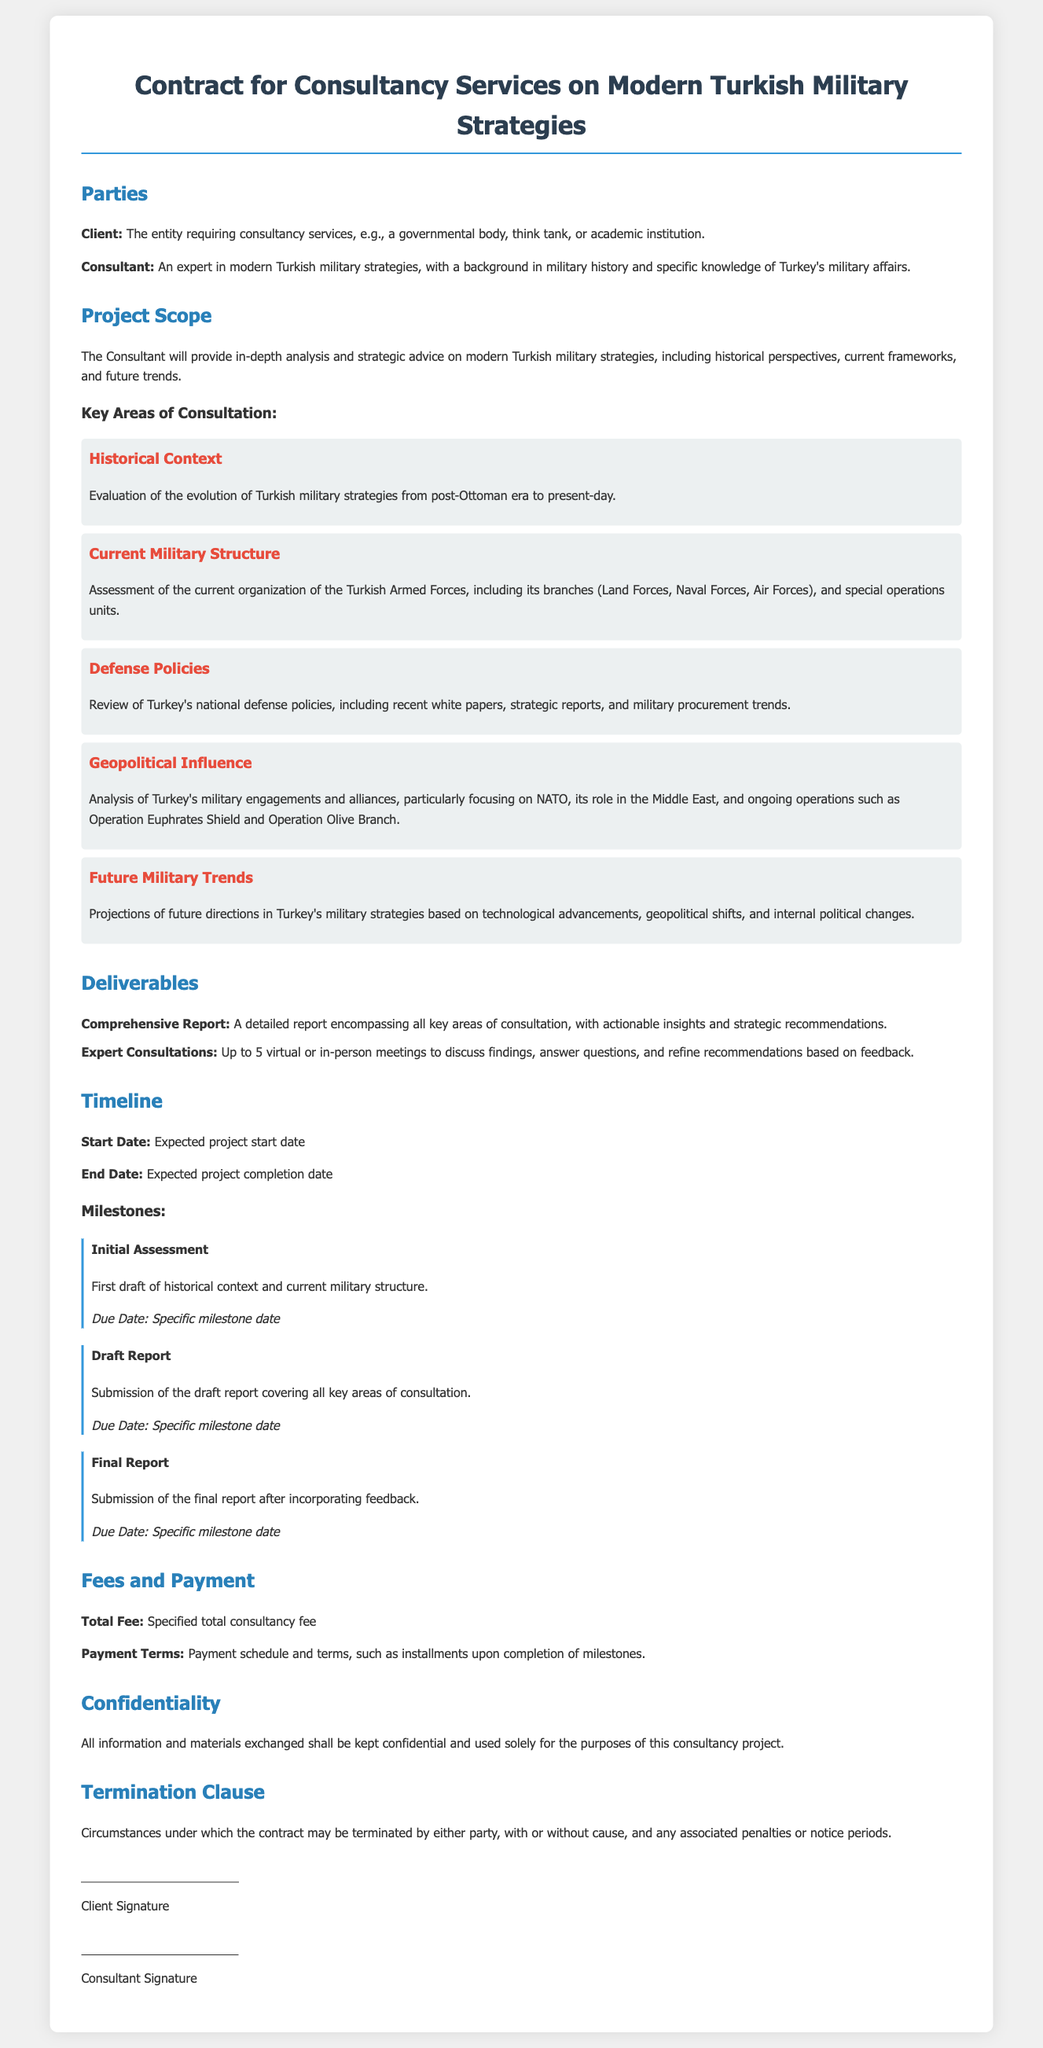What is the name of the document? The document is titled "Contract for Consultancy Services on Modern Turkish Military Strategies."
Answer: Contract for Consultancy Services on Modern Turkish Military Strategies Who is the client? The client is described as "The entity requiring consultancy services, e.g., a governmental body, think tank, or academic institution."
Answer: The entity requiring consultancy services, e.g., a governmental body, think tank, or academic institution What is the total fee? The total fee is indicated as "Specified total consultancy fee."
Answer: Specified total consultancy fee What are the key areas of consultation? The key areas of consultation are listed under "Key Areas of Consultation," which includes Historical Context, Current Military Structure, Defense Policies, Geopolitical Influence, and Future Military Trends.
Answer: Historical Context, Current Military Structure, Defense Policies, Geopolitical Influence, Future Military Trends What is the start date of the project? The start date is noted as "Expected project start date."
Answer: Expected project start date What is one of the deliverables? One of the deliverables specified is "Comprehensive Report."
Answer: Comprehensive Report When is the submission of the final report due? The due date for the final report is described as "Specific milestone date."
Answer: Specific milestone date What does the confidentiality clause ensure? The confidentiality clause states that "All information and materials exchanged shall be kept confidential."
Answer: All information and materials exchanged shall be kept confidential What is the assessment included in the project scope? The assessment included in the project scope is the "current organization of the Turkish Armed Forces."
Answer: current organization of the Turkish Armed Forces 